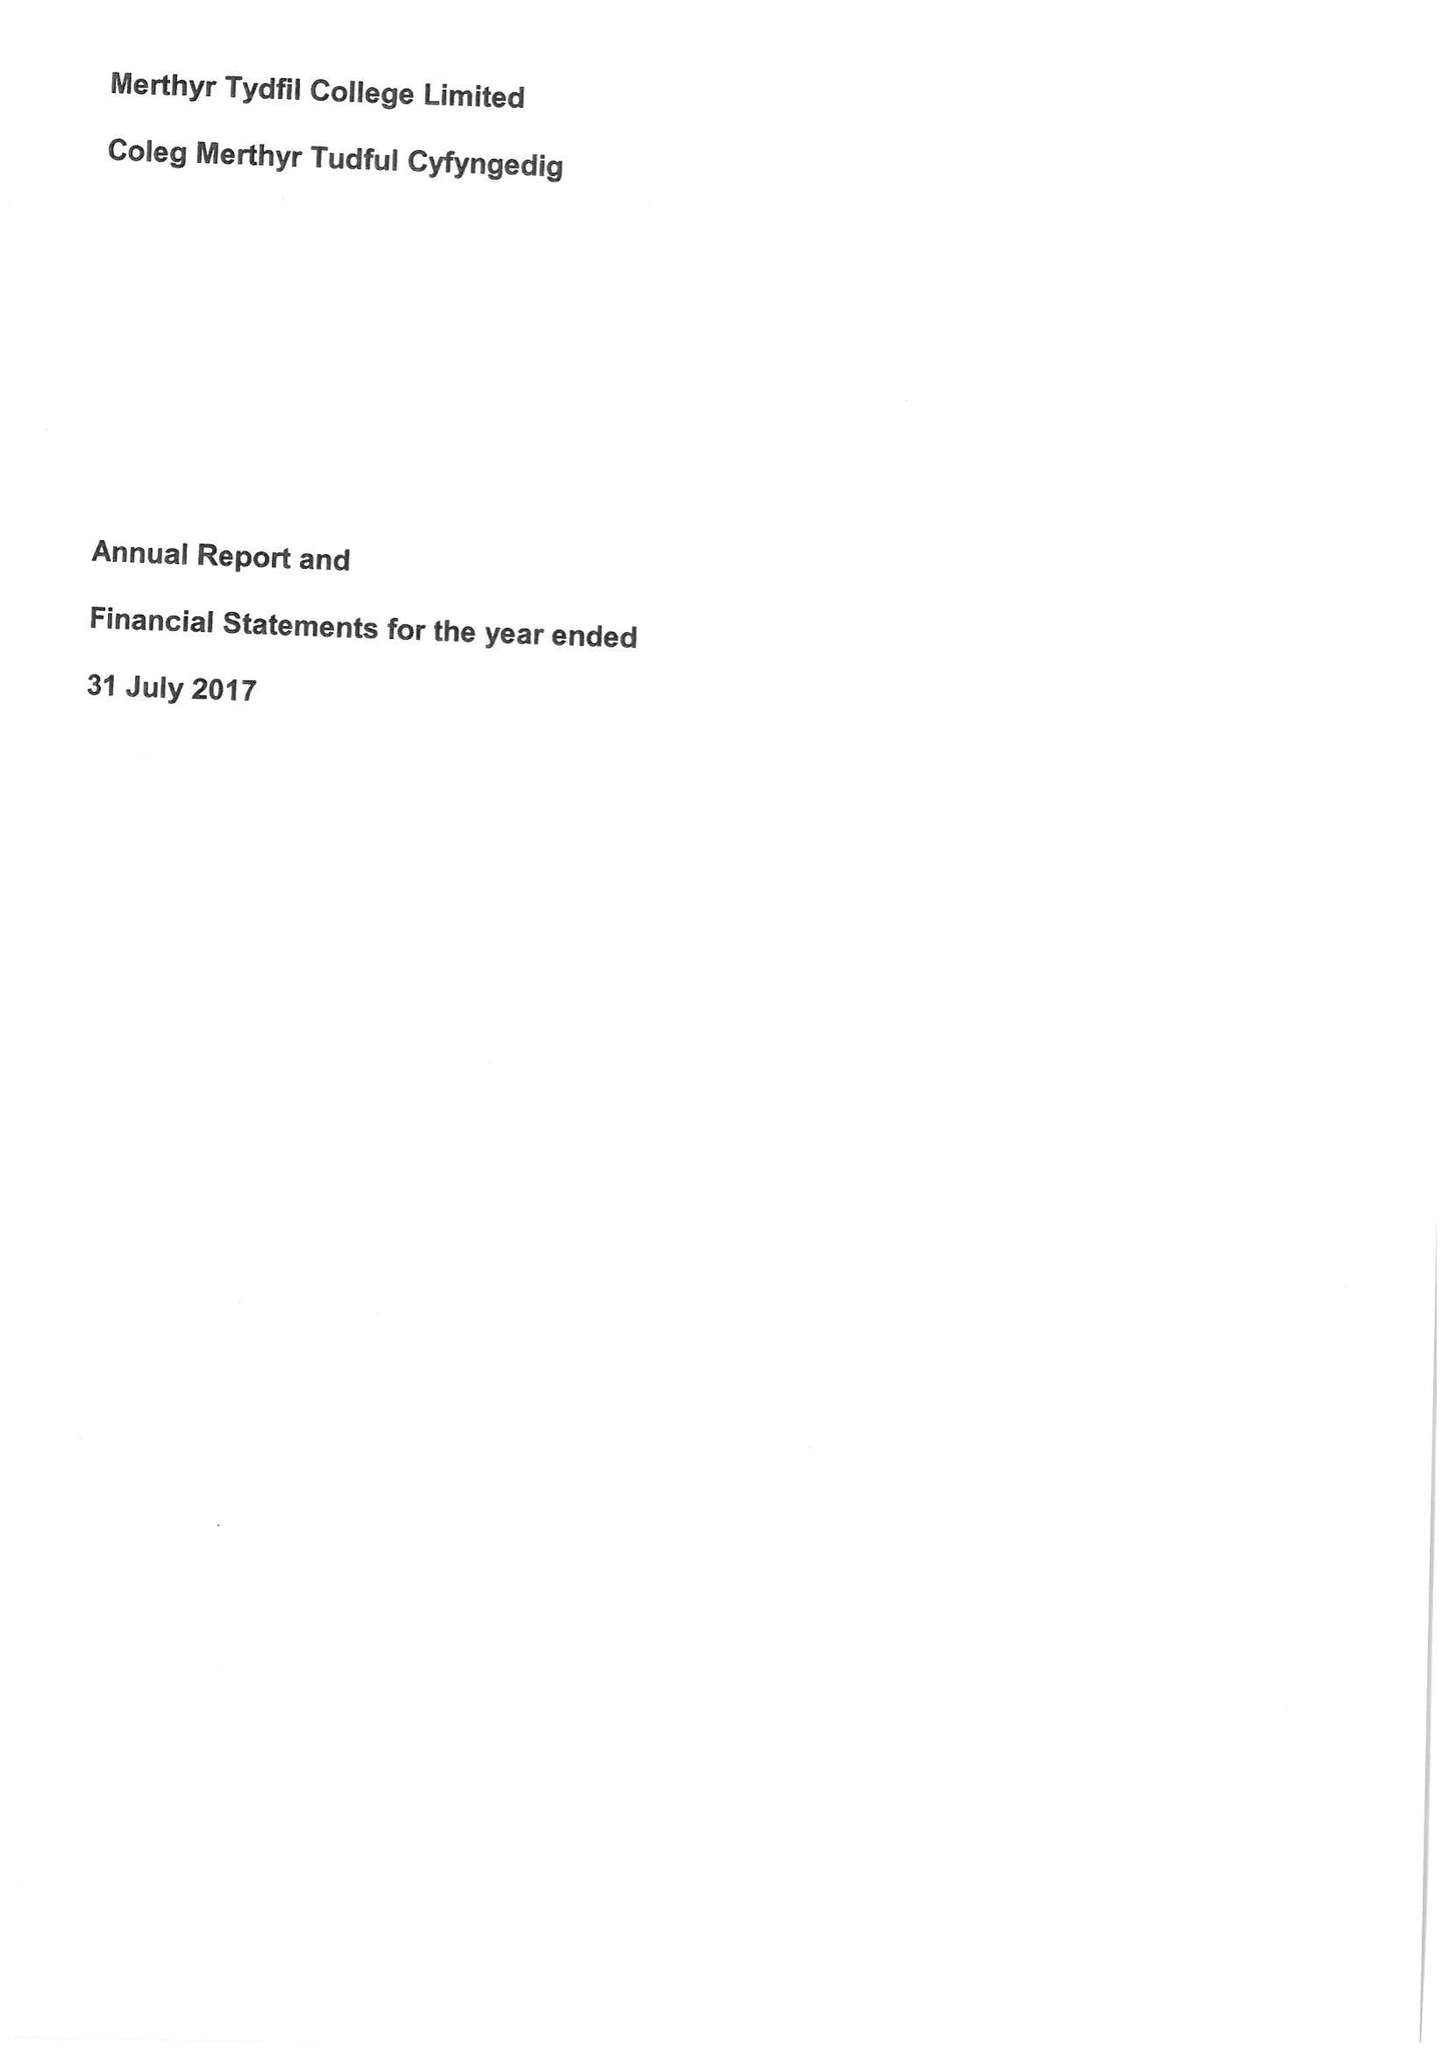What is the value for the charity_name?
Answer the question using a single word or phrase. Merthyr Tydfil College Ltd. 